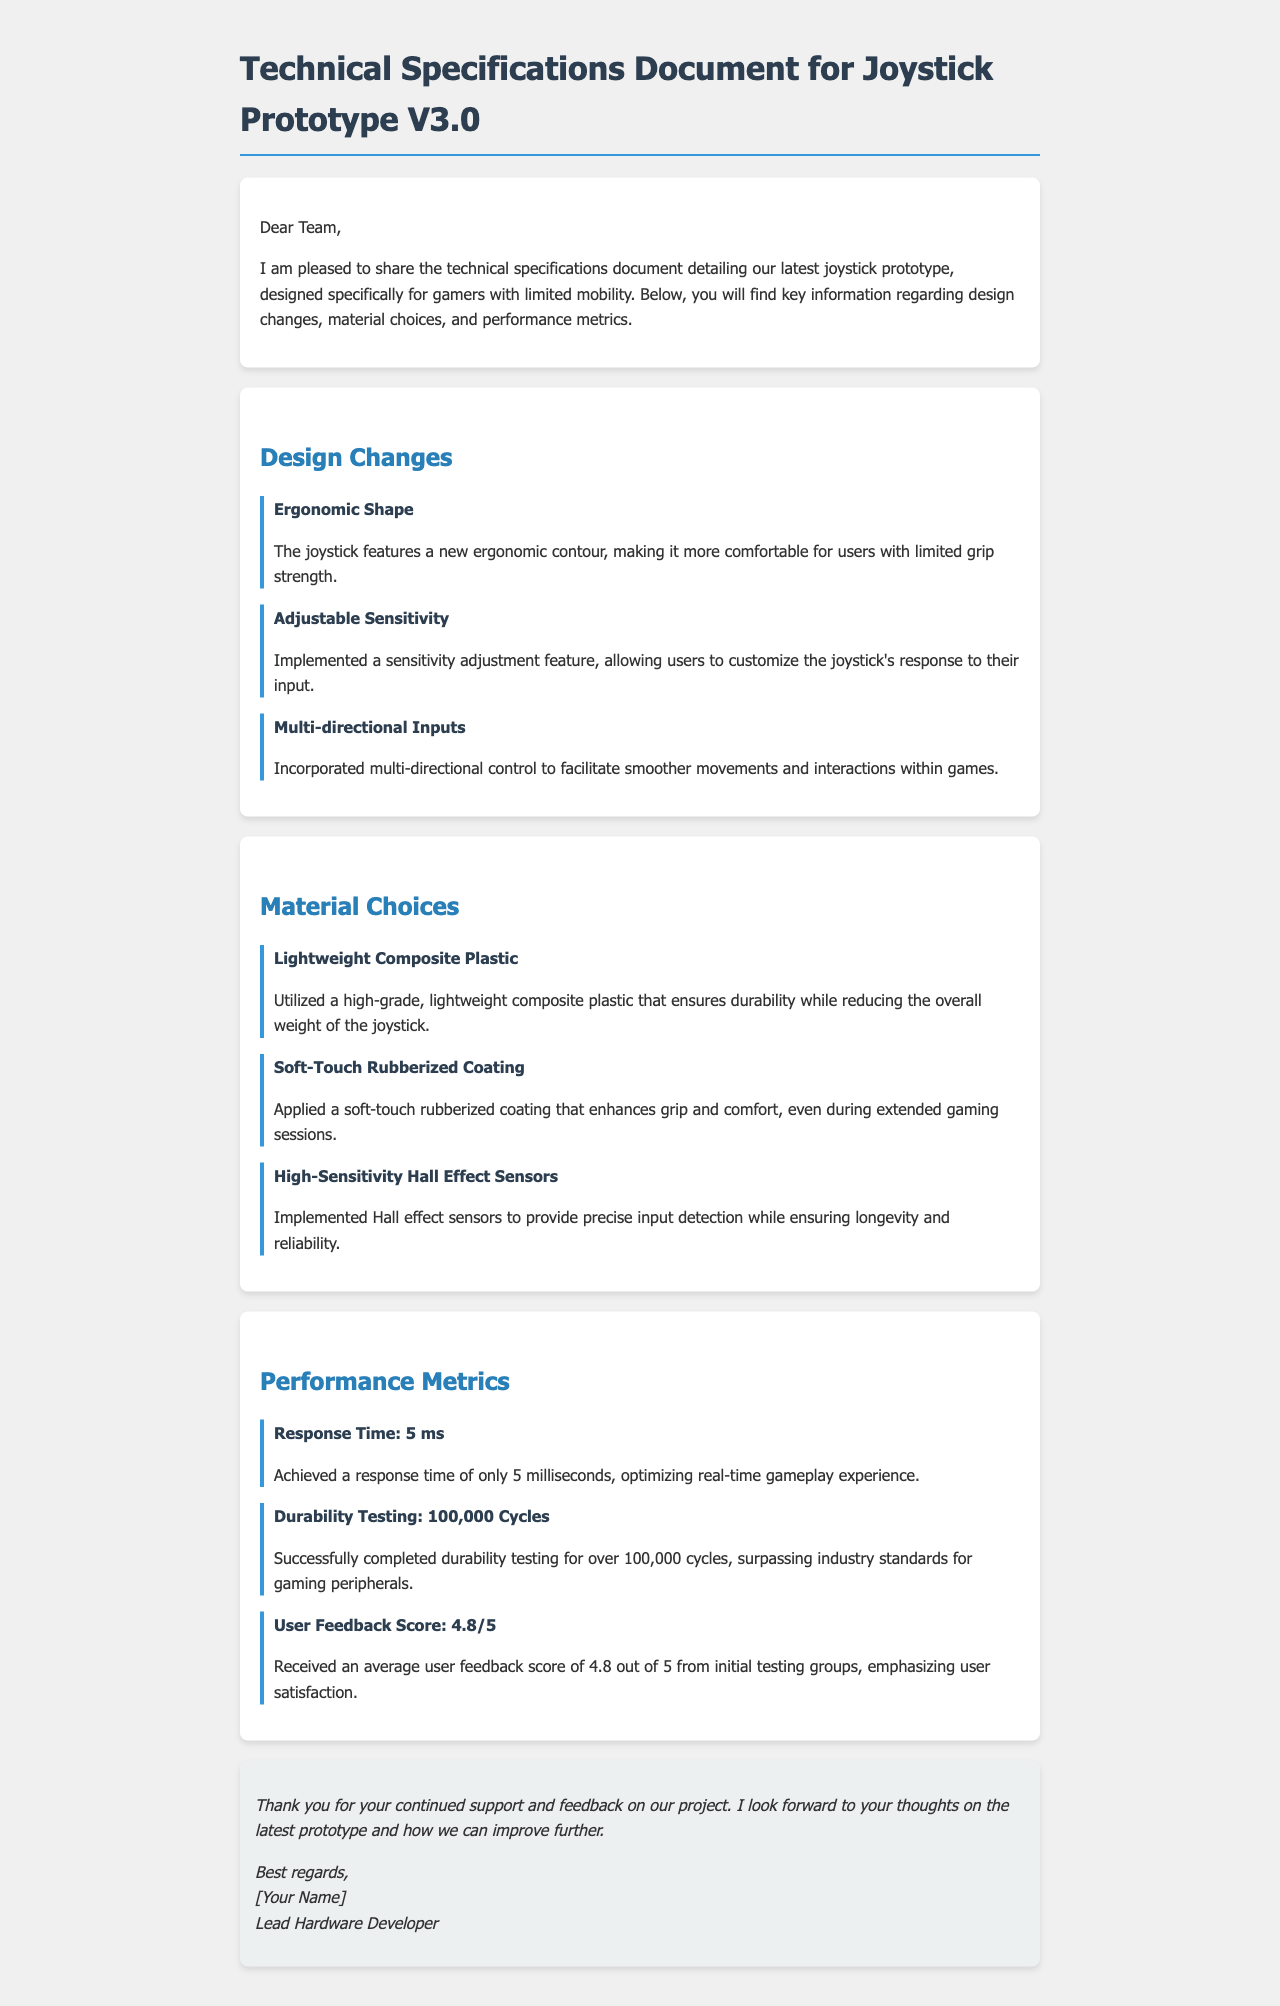What is the new shape feature of the joystick? The document states that the joystick features a new ergonomic contour for comfort.
Answer: Ergonomic Shape What was the user feedback score from initial testing groups? The document outlines that the user feedback score averaged 4.8 out of 5.
Answer: 4.8/5 How many cycles did the durability testing complete? According to the document, the joystick completed over 100,000 cycles of durability testing.
Answer: 100,000 Cycles What is the response time of the joystick? The document mentions the joystick has a response time of 5 milliseconds.
Answer: 5 ms What material is used for the joystick's coating? The document specifies that a soft-touch rubberized coating is applied for grip and comfort.
Answer: Soft-Touch Rubberized Coating How does the joystick allow for user customization? The document indicates that an adjustable sensitivity feature has been implemented for customization.
Answer: Adjustable Sensitivity What is one of the main design changes made to the joystick? The document highlights that multi-directional control was incorporated for smoother movements.
Answer: Multi-directional Inputs What type of sensors were implemented in the joystick? The document states that high-sensitivity Hall effect sensors were utilized for input detection.
Answer: Hall Effect Sensors What is the purpose of the lightweight composite plastic used? The document explains that it ensures durability while reducing the overall weight of the joystick.
Answer: Ensure durability and reduce weight 